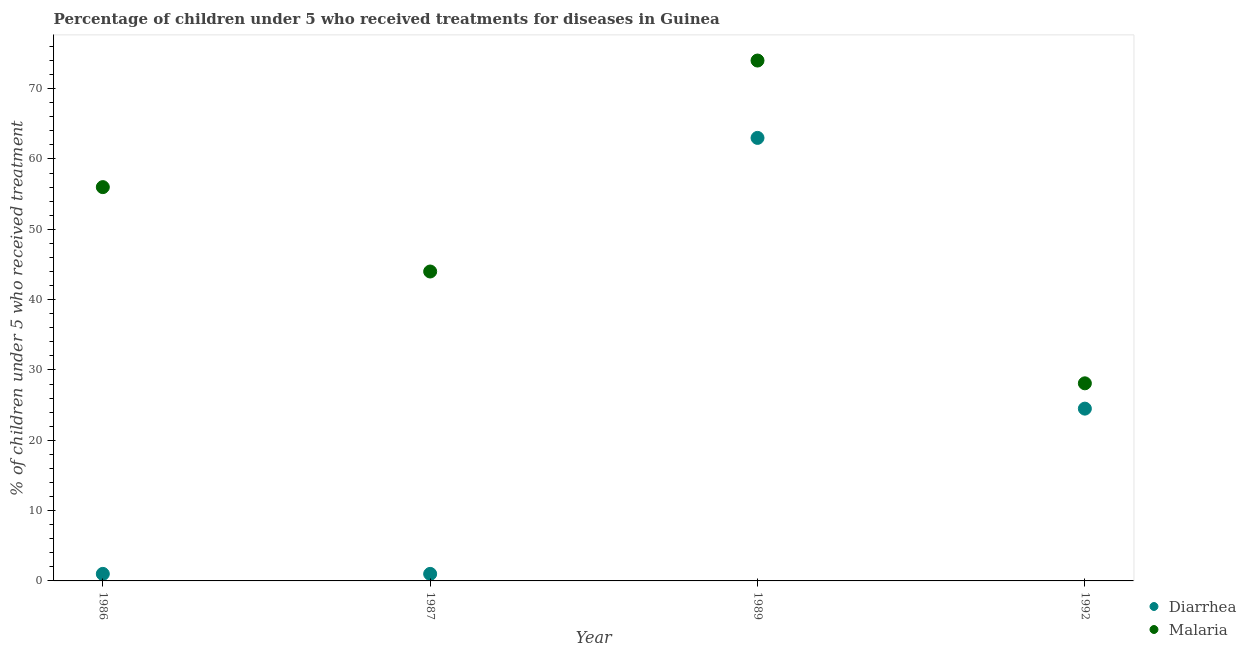Across all years, what is the maximum percentage of children who received treatment for malaria?
Offer a very short reply. 74. Across all years, what is the minimum percentage of children who received treatment for malaria?
Your response must be concise. 28.1. In which year was the percentage of children who received treatment for malaria minimum?
Provide a short and direct response. 1992. What is the total percentage of children who received treatment for malaria in the graph?
Offer a very short reply. 202.1. What is the difference between the percentage of children who received treatment for malaria in 1986 and that in 1992?
Provide a succinct answer. 27.9. What is the difference between the percentage of children who received treatment for malaria in 1989 and the percentage of children who received treatment for diarrhoea in 1992?
Offer a terse response. 49.5. What is the average percentage of children who received treatment for malaria per year?
Make the answer very short. 50.52. What is the ratio of the percentage of children who received treatment for malaria in 1989 to that in 1992?
Ensure brevity in your answer.  2.63. Is the percentage of children who received treatment for diarrhoea in 1987 less than that in 1992?
Provide a succinct answer. Yes. What is the difference between the highest and the lowest percentage of children who received treatment for diarrhoea?
Ensure brevity in your answer.  62. Is the sum of the percentage of children who received treatment for diarrhoea in 1986 and 1987 greater than the maximum percentage of children who received treatment for malaria across all years?
Offer a very short reply. No. Is the percentage of children who received treatment for malaria strictly greater than the percentage of children who received treatment for diarrhoea over the years?
Your answer should be very brief. Yes. How many dotlines are there?
Provide a short and direct response. 2. What is the difference between two consecutive major ticks on the Y-axis?
Offer a terse response. 10. Are the values on the major ticks of Y-axis written in scientific E-notation?
Provide a succinct answer. No. Does the graph contain any zero values?
Ensure brevity in your answer.  No. Does the graph contain grids?
Your answer should be compact. No. How many legend labels are there?
Make the answer very short. 2. How are the legend labels stacked?
Your answer should be compact. Vertical. What is the title of the graph?
Your answer should be very brief. Percentage of children under 5 who received treatments for diseases in Guinea. Does "Fertility rate" appear as one of the legend labels in the graph?
Provide a succinct answer. No. What is the label or title of the Y-axis?
Your response must be concise. % of children under 5 who received treatment. What is the % of children under 5 who received treatment of Diarrhea in 1987?
Give a very brief answer. 1. What is the % of children under 5 who received treatment in Diarrhea in 1989?
Provide a short and direct response. 63. What is the % of children under 5 who received treatment in Malaria in 1989?
Your response must be concise. 74. What is the % of children under 5 who received treatment in Diarrhea in 1992?
Keep it short and to the point. 24.5. What is the % of children under 5 who received treatment in Malaria in 1992?
Offer a terse response. 28.1. Across all years, what is the maximum % of children under 5 who received treatment in Diarrhea?
Provide a succinct answer. 63. Across all years, what is the maximum % of children under 5 who received treatment of Malaria?
Your response must be concise. 74. Across all years, what is the minimum % of children under 5 who received treatment of Diarrhea?
Provide a short and direct response. 1. Across all years, what is the minimum % of children under 5 who received treatment in Malaria?
Provide a succinct answer. 28.1. What is the total % of children under 5 who received treatment of Diarrhea in the graph?
Offer a terse response. 89.5. What is the total % of children under 5 who received treatment of Malaria in the graph?
Your response must be concise. 202.1. What is the difference between the % of children under 5 who received treatment in Diarrhea in 1986 and that in 1989?
Keep it short and to the point. -62. What is the difference between the % of children under 5 who received treatment of Malaria in 1986 and that in 1989?
Give a very brief answer. -18. What is the difference between the % of children under 5 who received treatment in Diarrhea in 1986 and that in 1992?
Make the answer very short. -23.5. What is the difference between the % of children under 5 who received treatment of Malaria in 1986 and that in 1992?
Offer a terse response. 27.9. What is the difference between the % of children under 5 who received treatment in Diarrhea in 1987 and that in 1989?
Your answer should be compact. -62. What is the difference between the % of children under 5 who received treatment of Malaria in 1987 and that in 1989?
Make the answer very short. -30. What is the difference between the % of children under 5 who received treatment in Diarrhea in 1987 and that in 1992?
Keep it short and to the point. -23.5. What is the difference between the % of children under 5 who received treatment in Malaria in 1987 and that in 1992?
Make the answer very short. 15.9. What is the difference between the % of children under 5 who received treatment of Diarrhea in 1989 and that in 1992?
Offer a very short reply. 38.5. What is the difference between the % of children under 5 who received treatment in Malaria in 1989 and that in 1992?
Your response must be concise. 45.9. What is the difference between the % of children under 5 who received treatment of Diarrhea in 1986 and the % of children under 5 who received treatment of Malaria in 1987?
Your response must be concise. -43. What is the difference between the % of children under 5 who received treatment of Diarrhea in 1986 and the % of children under 5 who received treatment of Malaria in 1989?
Offer a terse response. -73. What is the difference between the % of children under 5 who received treatment of Diarrhea in 1986 and the % of children under 5 who received treatment of Malaria in 1992?
Give a very brief answer. -27.1. What is the difference between the % of children under 5 who received treatment in Diarrhea in 1987 and the % of children under 5 who received treatment in Malaria in 1989?
Ensure brevity in your answer.  -73. What is the difference between the % of children under 5 who received treatment in Diarrhea in 1987 and the % of children under 5 who received treatment in Malaria in 1992?
Provide a short and direct response. -27.1. What is the difference between the % of children under 5 who received treatment in Diarrhea in 1989 and the % of children under 5 who received treatment in Malaria in 1992?
Give a very brief answer. 34.9. What is the average % of children under 5 who received treatment in Diarrhea per year?
Provide a short and direct response. 22.38. What is the average % of children under 5 who received treatment of Malaria per year?
Provide a succinct answer. 50.52. In the year 1986, what is the difference between the % of children under 5 who received treatment in Diarrhea and % of children under 5 who received treatment in Malaria?
Your answer should be very brief. -55. In the year 1987, what is the difference between the % of children under 5 who received treatment of Diarrhea and % of children under 5 who received treatment of Malaria?
Your response must be concise. -43. In the year 1989, what is the difference between the % of children under 5 who received treatment in Diarrhea and % of children under 5 who received treatment in Malaria?
Offer a terse response. -11. What is the ratio of the % of children under 5 who received treatment of Diarrhea in 1986 to that in 1987?
Provide a succinct answer. 1. What is the ratio of the % of children under 5 who received treatment of Malaria in 1986 to that in 1987?
Ensure brevity in your answer.  1.27. What is the ratio of the % of children under 5 who received treatment of Diarrhea in 1986 to that in 1989?
Offer a very short reply. 0.02. What is the ratio of the % of children under 5 who received treatment of Malaria in 1986 to that in 1989?
Provide a short and direct response. 0.76. What is the ratio of the % of children under 5 who received treatment in Diarrhea in 1986 to that in 1992?
Give a very brief answer. 0.04. What is the ratio of the % of children under 5 who received treatment of Malaria in 1986 to that in 1992?
Ensure brevity in your answer.  1.99. What is the ratio of the % of children under 5 who received treatment in Diarrhea in 1987 to that in 1989?
Ensure brevity in your answer.  0.02. What is the ratio of the % of children under 5 who received treatment of Malaria in 1987 to that in 1989?
Your response must be concise. 0.59. What is the ratio of the % of children under 5 who received treatment of Diarrhea in 1987 to that in 1992?
Offer a very short reply. 0.04. What is the ratio of the % of children under 5 who received treatment in Malaria in 1987 to that in 1992?
Your answer should be very brief. 1.57. What is the ratio of the % of children under 5 who received treatment of Diarrhea in 1989 to that in 1992?
Your response must be concise. 2.57. What is the ratio of the % of children under 5 who received treatment of Malaria in 1989 to that in 1992?
Provide a short and direct response. 2.63. What is the difference between the highest and the second highest % of children under 5 who received treatment in Diarrhea?
Your answer should be very brief. 38.5. What is the difference between the highest and the lowest % of children under 5 who received treatment in Malaria?
Offer a terse response. 45.9. 